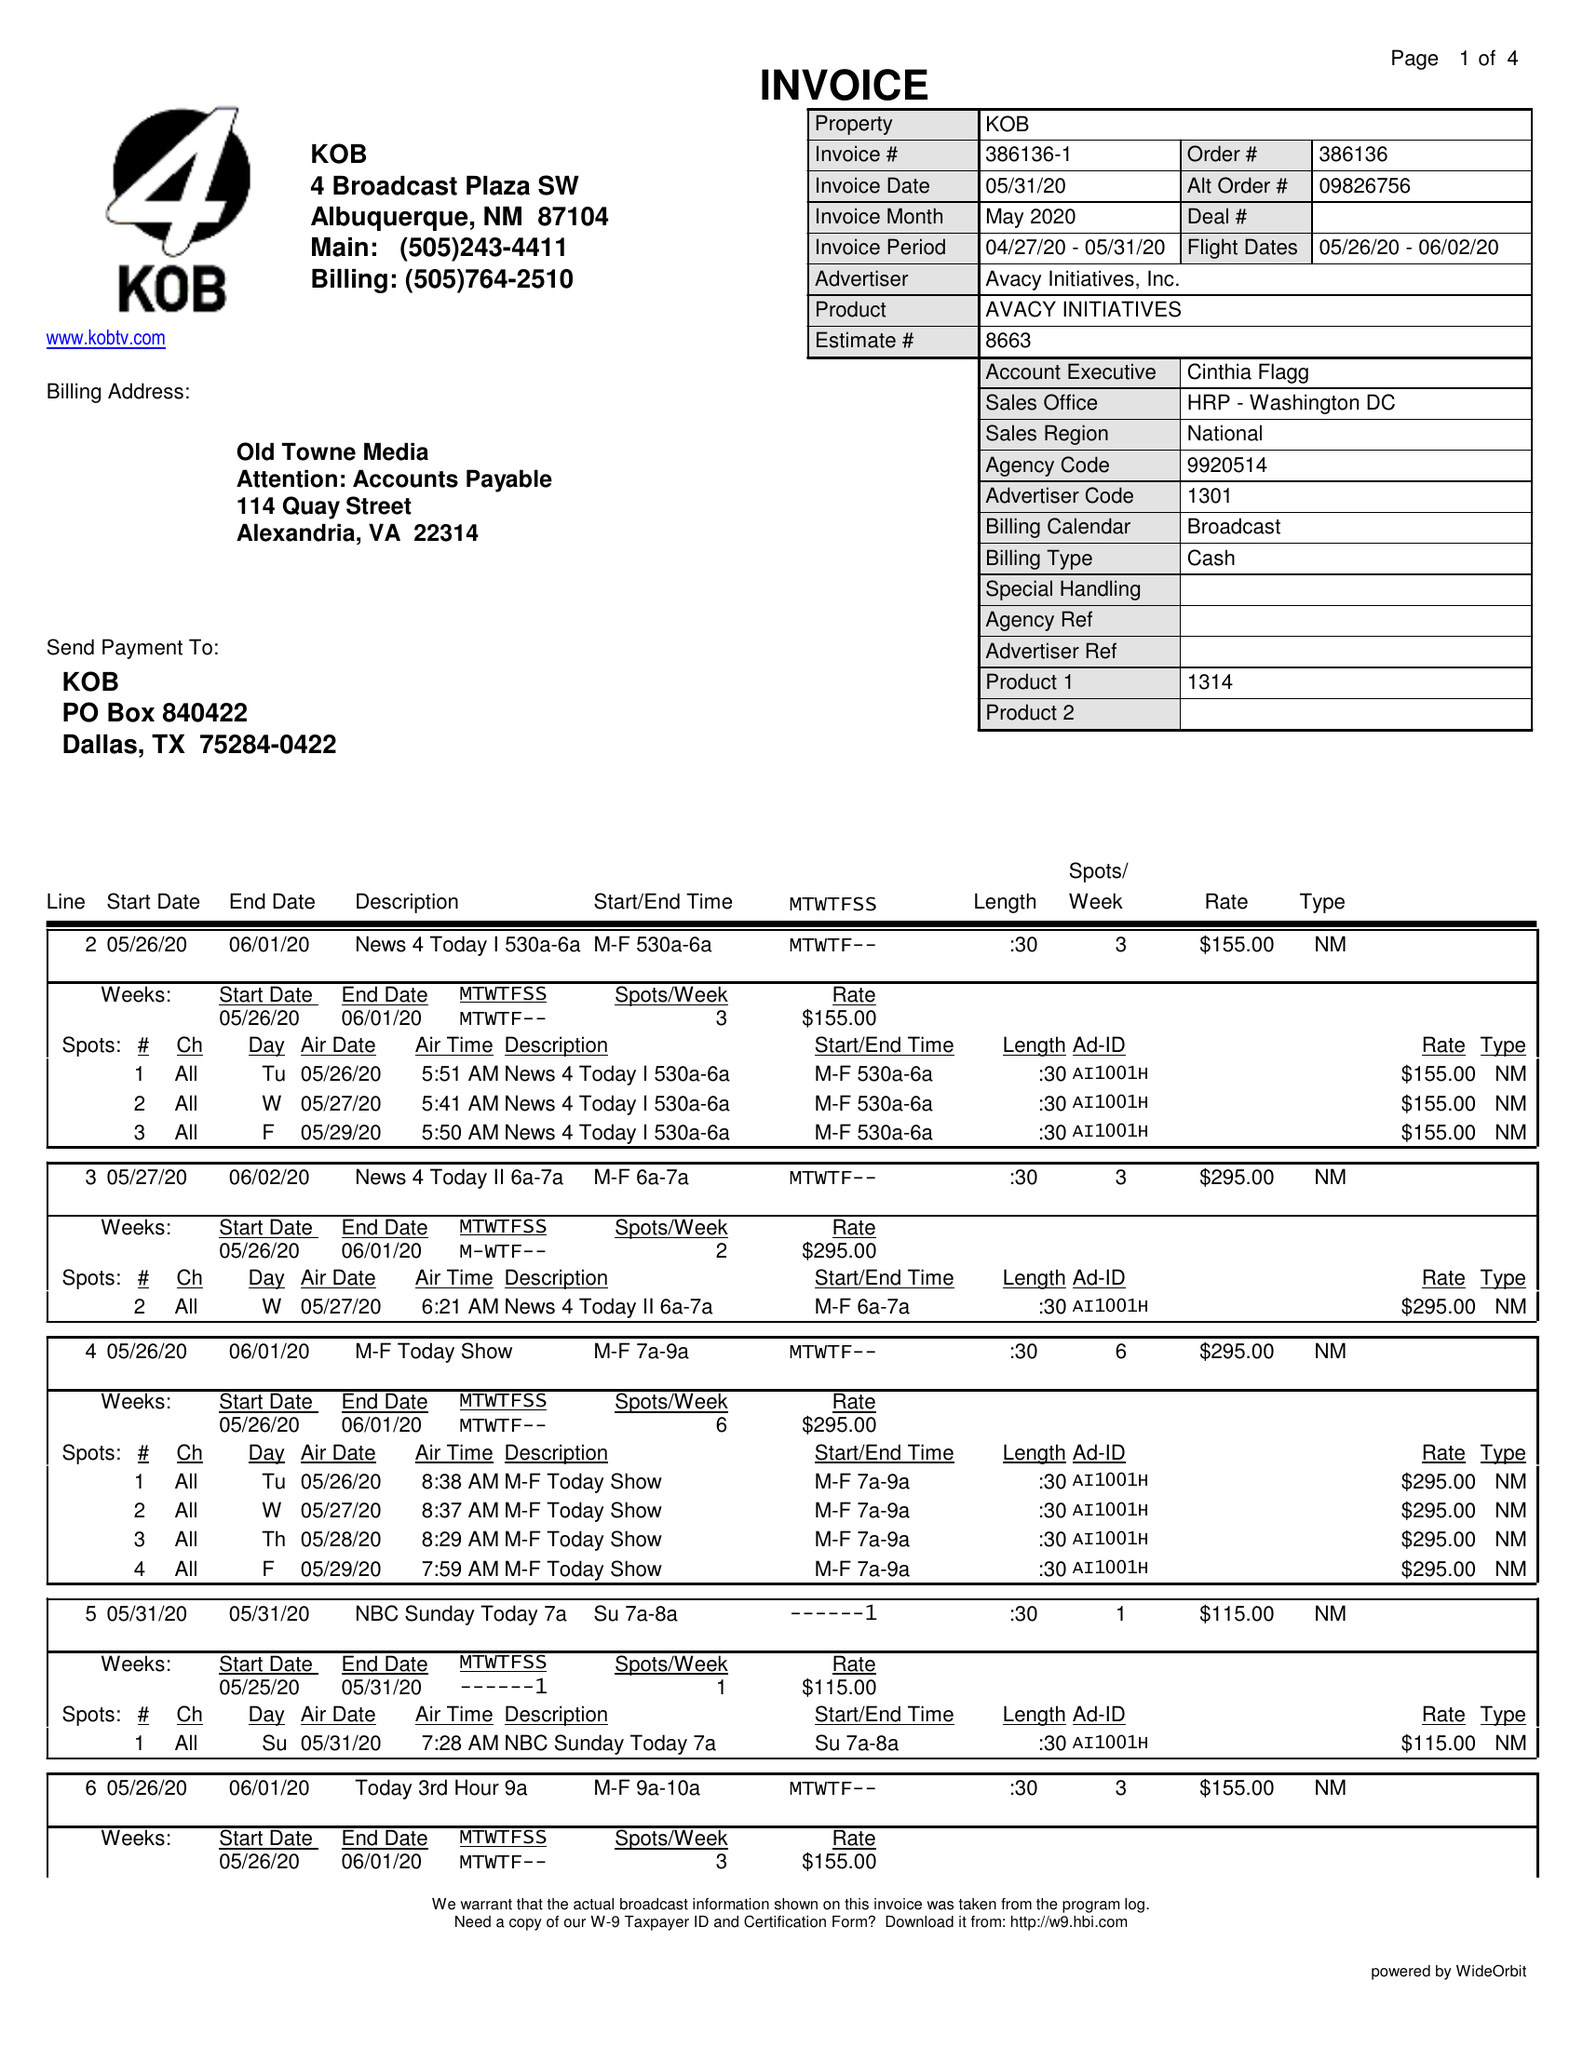What is the value for the contract_num?
Answer the question using a single word or phrase. 386136 